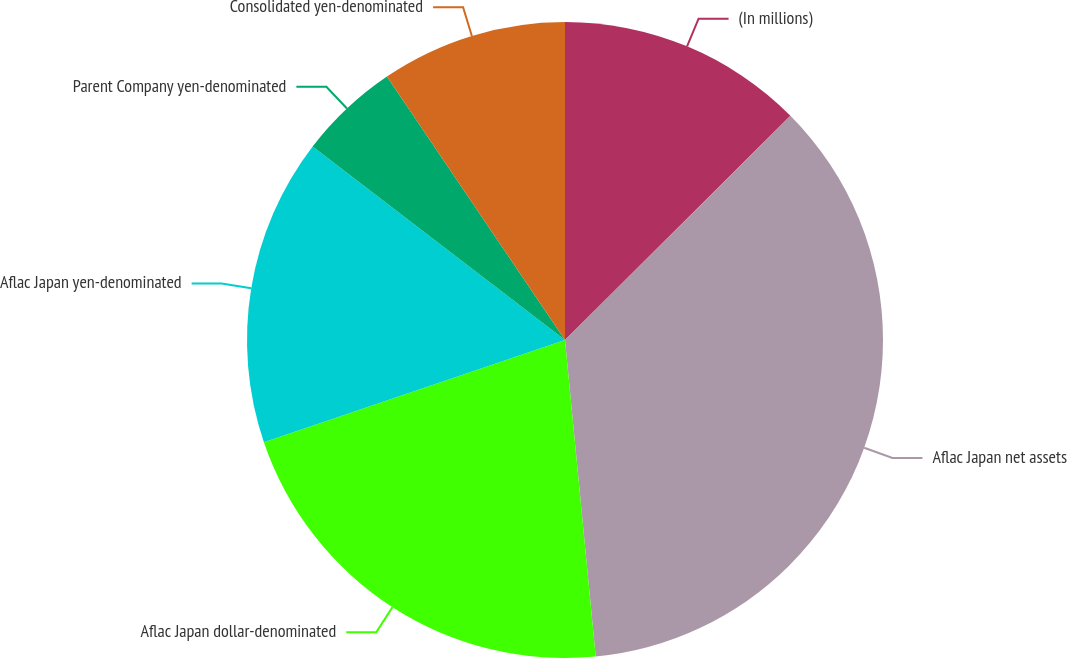<chart> <loc_0><loc_0><loc_500><loc_500><pie_chart><fcel>(In millions)<fcel>Aflac Japan net assets<fcel>Aflac Japan dollar-denominated<fcel>Aflac Japan yen-denominated<fcel>Parent Company yen-denominated<fcel>Consolidated yen-denominated<nl><fcel>12.54%<fcel>35.92%<fcel>21.33%<fcel>15.62%<fcel>5.13%<fcel>9.46%<nl></chart> 